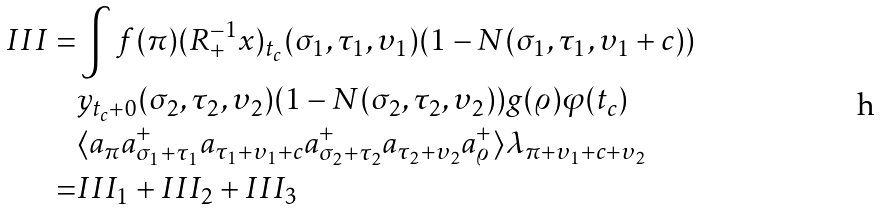<formula> <loc_0><loc_0><loc_500><loc_500>I I I = & \int f ( \pi ) ( R ^ { - 1 } _ { + } x ) _ { t _ { c } } ( \sigma _ { 1 } , \tau _ { 1 } , \upsilon _ { 1 } ) ( 1 - N ( \sigma _ { 1 } , \tau _ { 1 } , \upsilon _ { 1 } + c ) ) \\ & y _ { t _ { c } + 0 } ( \sigma _ { 2 } , \tau _ { 2 } , \upsilon _ { 2 } ) ( 1 - N ( \sigma _ { 2 } , \tau _ { 2 } , \upsilon _ { 2 } ) ) g ( \varrho ) \varphi ( t _ { c } ) \\ & \langle a _ { \pi } a ^ { + } _ { \sigma _ { 1 } + \tau _ { 1 } } a _ { \tau _ { 1 } + \upsilon _ { 1 } + c } a ^ { + } _ { \sigma _ { 2 } + \tau _ { 2 } } a _ { \tau _ { 2 } + \upsilon _ { 2 } } a ^ { + } _ { \varrho } \rangle \lambda _ { \pi + \upsilon _ { 1 } + c + \upsilon _ { 2 } } \\ = & I I I _ { 1 } + I I I _ { 2 } + I I I _ { 3 }</formula> 